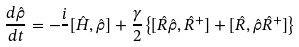<formula> <loc_0><loc_0><loc_500><loc_500>\frac { d \hat { \rho } } { d t } = - \frac { i } { } [ \hat { H } , \hat { \rho } ] + \frac { \gamma } { 2 } \left \{ [ \hat { R } \hat { \rho } , \hat { R } ^ { + } ] + [ \hat { R } , \hat { \rho } \hat { R } ^ { + } ] \right \}</formula> 